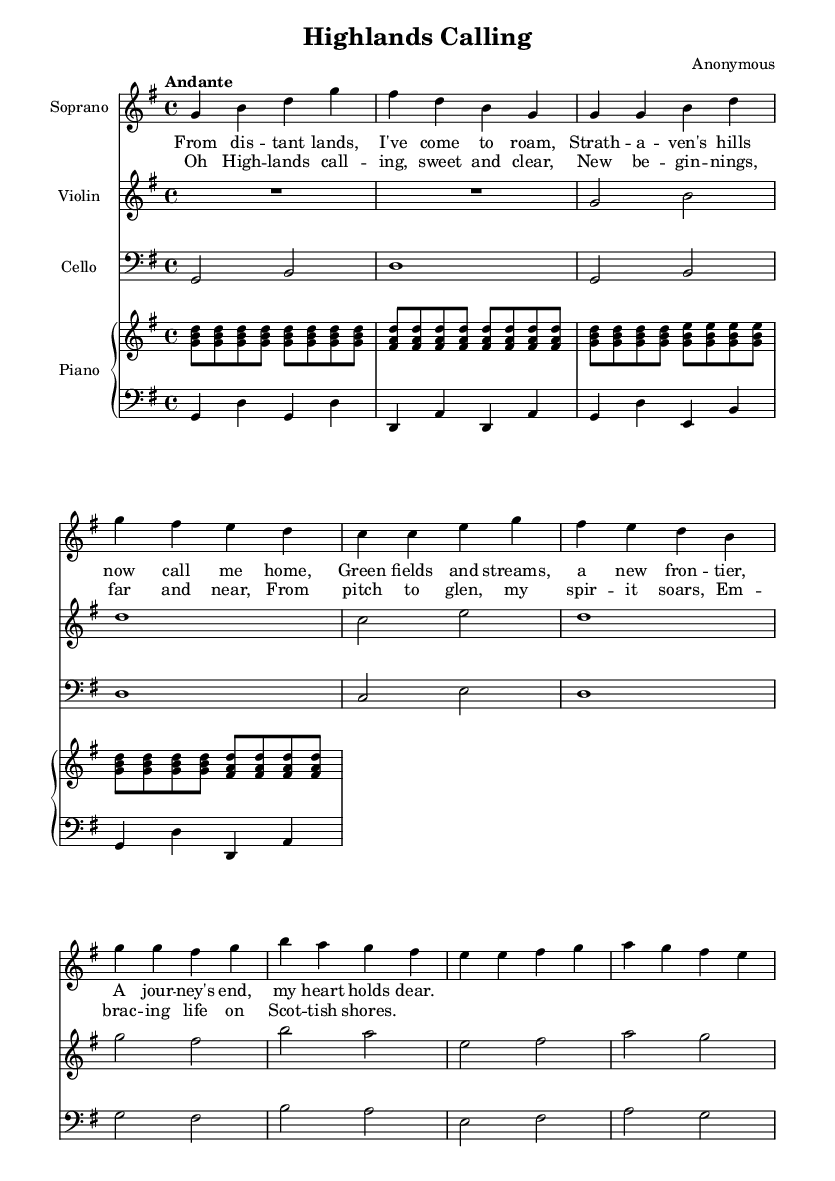What is the key signature of this music? The key signature is indicated at the beginning of the music with one sharp (the F sharp). This means that every F note played in the piece should be sharp throughout.
Answer: G major What is the time signature of this music? The time signature is indicated at the beginning of the music with the numbers "4/4." This means there are four beats in each measure and the quarter note receives one beat.
Answer: 4/4 What is the tempo marking for this piece? The tempo marking is shown at the beginning as "Andante," which refers to a moderately slow pace. This indicates how fast the music should be played.
Answer: Andante How many measures are there in the soprano part? By counting the vertical lines (bar lines) that separate the measures in the soprano part, we find there are 8 measures.
Answer: 8 What is the theme of the lyrics provided in the soprano part? The lyrics express a journey of relocation and finding a new home in Strathaven, emphasizing natural beauty and a sense of belonging. This is evident from phrases like "Strathaven's hills now call me home" and "A journey's end, my heart holds dear."
Answer: Journey and belonging What instruments are included in this score? The score includes a soprano voice, violin, cello, and piano (with separate right and left hand parts). Each of these instruments is specified at the beginning of their respective staff.
Answer: Soprano, Violin, Cello, Piano What is the form of the piece based on the lyrics? The piece features a structured format that consists of verses followed by a chorus. The alternation between these sections is typical in opera and highlights the thematic elements of the journey and relocation expressed in the lyrics.
Answer: Verse and Chorus 